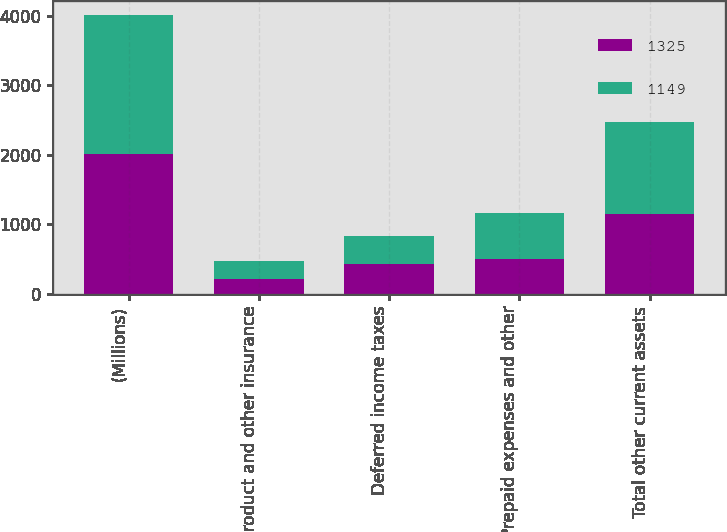<chart> <loc_0><loc_0><loc_500><loc_500><stacked_bar_chart><ecel><fcel>(Millions)<fcel>Product and other insurance<fcel>Deferred income taxes<fcel>Prepaid expenses and other<fcel>Total other current assets<nl><fcel>1325<fcel>2007<fcel>220<fcel>428<fcel>501<fcel>1149<nl><fcel>1149<fcel>2006<fcel>255<fcel>412<fcel>658<fcel>1325<nl></chart> 